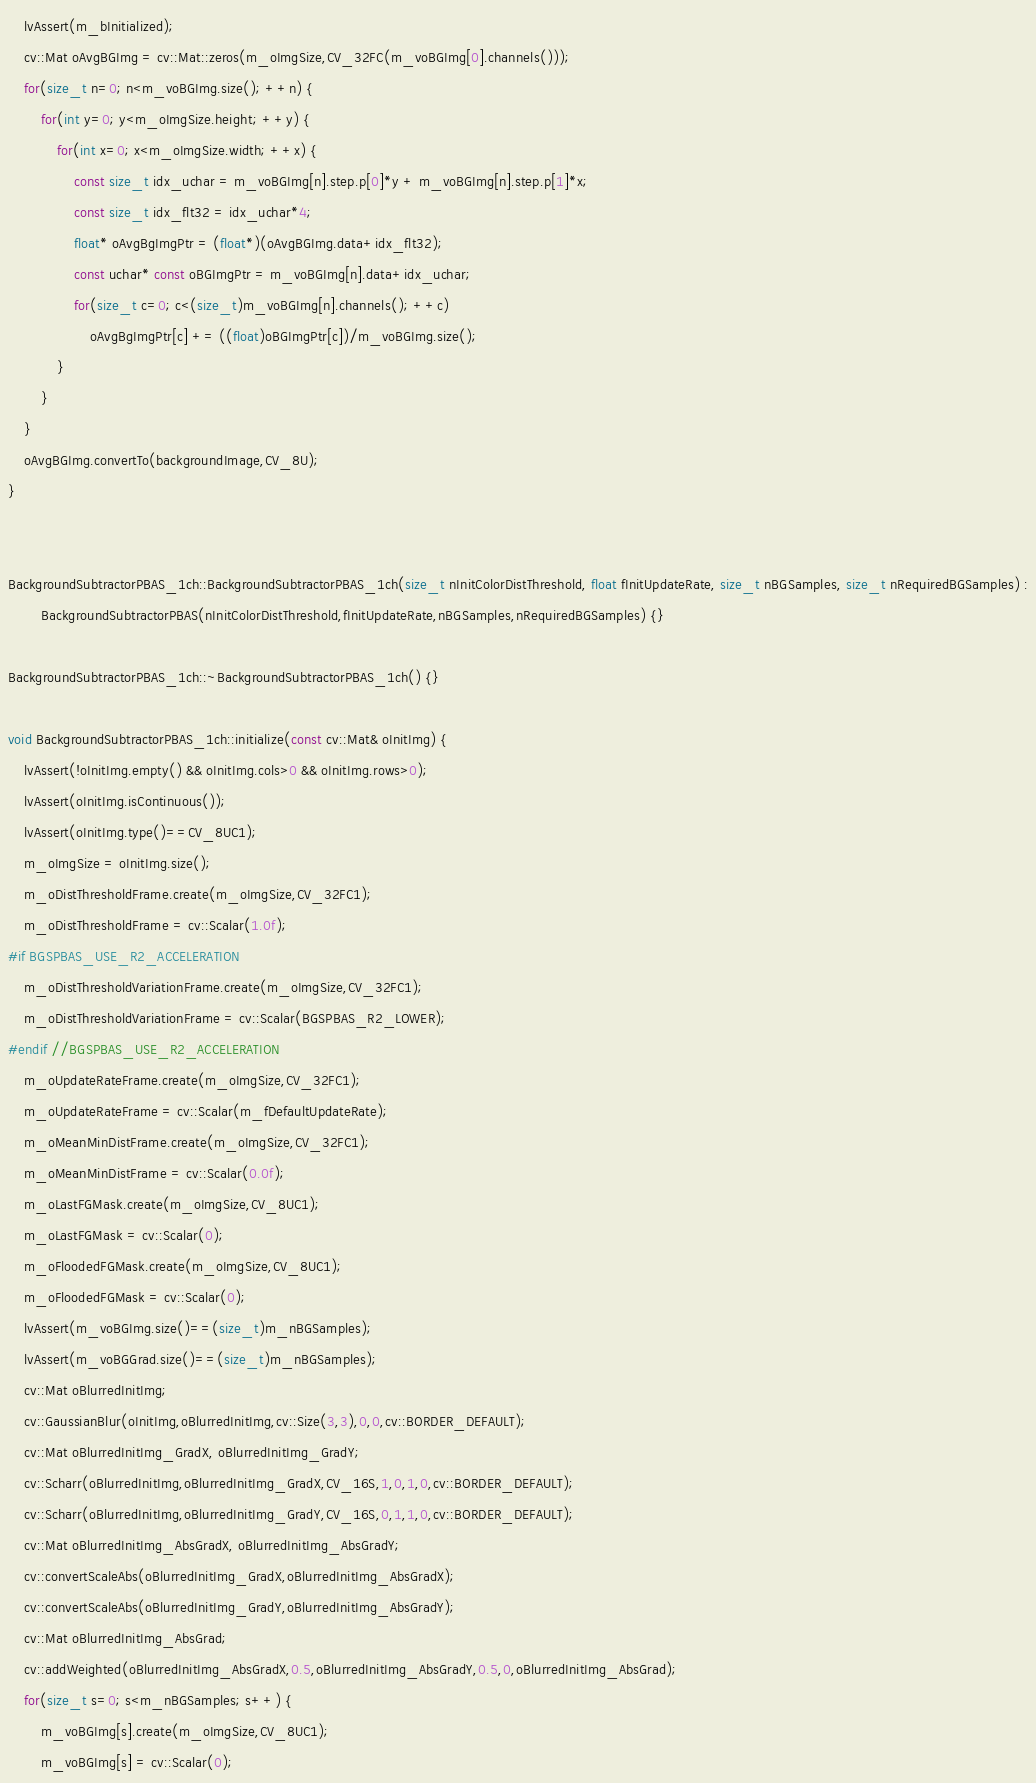<code> <loc_0><loc_0><loc_500><loc_500><_C++_>    lvAssert(m_bInitialized);
    cv::Mat oAvgBGImg = cv::Mat::zeros(m_oImgSize,CV_32FC(m_voBGImg[0].channels()));
    for(size_t n=0; n<m_voBGImg.size(); ++n) {
        for(int y=0; y<m_oImgSize.height; ++y) {
            for(int x=0; x<m_oImgSize.width; ++x) {
                const size_t idx_uchar = m_voBGImg[n].step.p[0]*y + m_voBGImg[n].step.p[1]*x;
                const size_t idx_flt32 = idx_uchar*4;
                float* oAvgBgImgPtr = (float*)(oAvgBGImg.data+idx_flt32);
                const uchar* const oBGImgPtr = m_voBGImg[n].data+idx_uchar;
                for(size_t c=0; c<(size_t)m_voBGImg[n].channels(); ++c)
                    oAvgBgImgPtr[c] += ((float)oBGImgPtr[c])/m_voBGImg.size();
            }
        }
    }
    oAvgBGImg.convertTo(backgroundImage,CV_8U);
}


BackgroundSubtractorPBAS_1ch::BackgroundSubtractorPBAS_1ch(size_t nInitColorDistThreshold, float fInitUpdateRate, size_t nBGSamples, size_t nRequiredBGSamples) :
        BackgroundSubtractorPBAS(nInitColorDistThreshold,fInitUpdateRate,nBGSamples,nRequiredBGSamples) {}

BackgroundSubtractorPBAS_1ch::~BackgroundSubtractorPBAS_1ch() {}

void BackgroundSubtractorPBAS_1ch::initialize(const cv::Mat& oInitImg) {
    lvAssert(!oInitImg.empty() && oInitImg.cols>0 && oInitImg.rows>0);
    lvAssert(oInitImg.isContinuous());
    lvAssert(oInitImg.type()==CV_8UC1);
    m_oImgSize = oInitImg.size();
    m_oDistThresholdFrame.create(m_oImgSize,CV_32FC1);
    m_oDistThresholdFrame = cv::Scalar(1.0f);
#if BGSPBAS_USE_R2_ACCELERATION
    m_oDistThresholdVariationFrame.create(m_oImgSize,CV_32FC1);
    m_oDistThresholdVariationFrame = cv::Scalar(BGSPBAS_R2_LOWER);
#endif //BGSPBAS_USE_R2_ACCELERATION
    m_oUpdateRateFrame.create(m_oImgSize,CV_32FC1);
    m_oUpdateRateFrame = cv::Scalar(m_fDefaultUpdateRate);
    m_oMeanMinDistFrame.create(m_oImgSize,CV_32FC1);
    m_oMeanMinDistFrame = cv::Scalar(0.0f);
    m_oLastFGMask.create(m_oImgSize,CV_8UC1);
    m_oLastFGMask = cv::Scalar(0);
    m_oFloodedFGMask.create(m_oImgSize,CV_8UC1);
    m_oFloodedFGMask = cv::Scalar(0);
    lvAssert(m_voBGImg.size()==(size_t)m_nBGSamples);
    lvAssert(m_voBGGrad.size()==(size_t)m_nBGSamples);
    cv::Mat oBlurredInitImg;
    cv::GaussianBlur(oInitImg,oBlurredInitImg,cv::Size(3,3),0,0,cv::BORDER_DEFAULT);
    cv::Mat oBlurredInitImg_GradX, oBlurredInitImg_GradY;
    cv::Scharr(oBlurredInitImg,oBlurredInitImg_GradX,CV_16S,1,0,1,0,cv::BORDER_DEFAULT);
    cv::Scharr(oBlurredInitImg,oBlurredInitImg_GradY,CV_16S,0,1,1,0,cv::BORDER_DEFAULT);
    cv::Mat oBlurredInitImg_AbsGradX, oBlurredInitImg_AbsGradY;
    cv::convertScaleAbs(oBlurredInitImg_GradX,oBlurredInitImg_AbsGradX);
    cv::convertScaleAbs(oBlurredInitImg_GradY,oBlurredInitImg_AbsGradY);
    cv::Mat oBlurredInitImg_AbsGrad;
    cv::addWeighted(oBlurredInitImg_AbsGradX,0.5,oBlurredInitImg_AbsGradY,0.5,0,oBlurredInitImg_AbsGrad);
    for(size_t s=0; s<m_nBGSamples; s++) {
        m_voBGImg[s].create(m_oImgSize,CV_8UC1);
        m_voBGImg[s] = cv::Scalar(0);</code> 